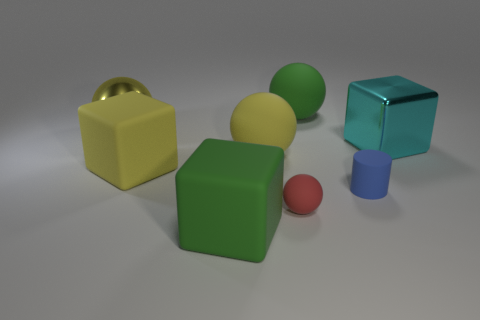Subtract all big green matte cubes. How many cubes are left? 2 Subtract 4 balls. How many balls are left? 0 Add 2 big cyan shiny cubes. How many objects exist? 10 Subtract all red spheres. How many spheres are left? 3 Subtract all blocks. How many objects are left? 5 Subtract all blue cubes. How many yellow spheres are left? 2 Add 1 blue objects. How many blue objects are left? 2 Add 5 gray things. How many gray things exist? 5 Subtract 1 red balls. How many objects are left? 7 Subtract all yellow spheres. Subtract all blue cubes. How many spheres are left? 2 